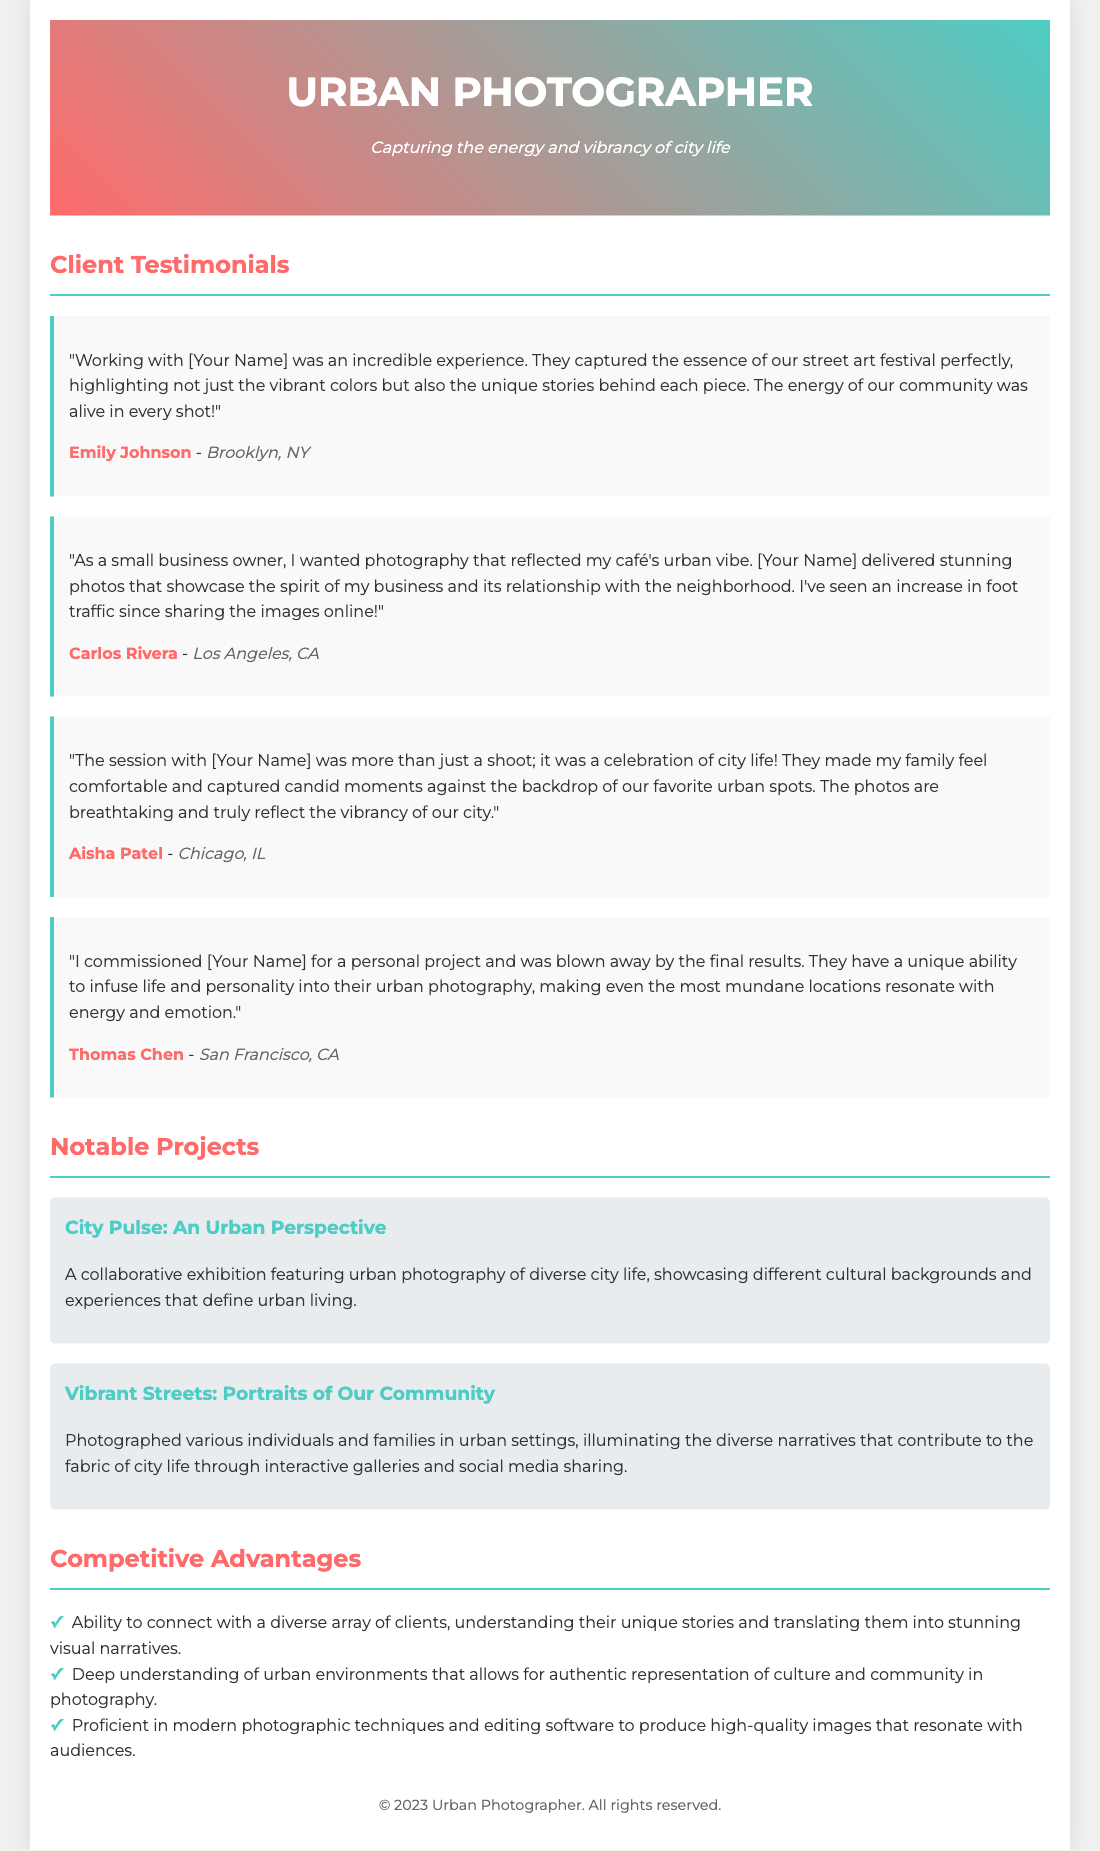what is the name of the photographer? The name of the photographer is indicated in the header of the document as "Urban Photographer."
Answer: Urban Photographer who provided a testimonial about a street art festival? The testimonial mentioning the street art festival is from Emily Johnson, who expresses excitement about the captured essence of the event.
Answer: Emily Johnson which city is Carlos Rivera located in? The document states that Carlos Rivera is located in Los Angeles, CA.
Answer: Los Angeles, CA what is one of the notable projects mentioned in the document? The document lists "City Pulse: An Urban Perspective" as one of the notable projects highlighting urban photography.
Answer: City Pulse: An Urban Perspective how many testimonials are listed in the document? There are a total of four client testimonials included in the document.
Answer: Four what advantage is highlighted regarding the photographer's ability? The document highlights the ability to connect with a diverse array of clients and understand their unique stories.
Answer: Connect with a diverse array of clients which type of photography does the document emphasize? The document emphasizes urban photography, focusing on city life and vibrancy.
Answer: Urban photography who is the client that mentioned seeing an increase in foot traffic? The client who mentioned an increase in foot traffic after sharing images is Carlos Rivera.
Answer: Carlos Rivera what is the style of the photographer's tagline? The tagline describing the photographer's vision is "Capturing the energy and vibrancy of city life."
Answer: Capturing the energy and vibrancy of city life 